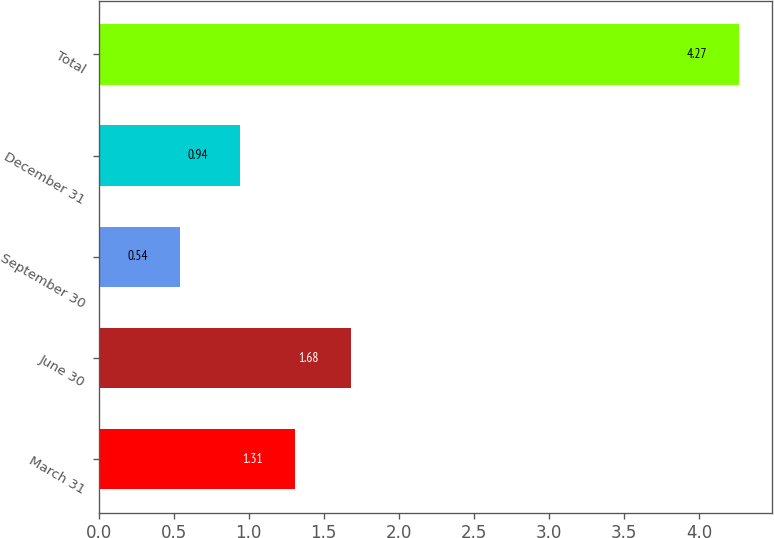Convert chart to OTSL. <chart><loc_0><loc_0><loc_500><loc_500><bar_chart><fcel>March 31<fcel>June 30<fcel>September 30<fcel>December 31<fcel>Total<nl><fcel>1.31<fcel>1.68<fcel>0.54<fcel>0.94<fcel>4.27<nl></chart> 